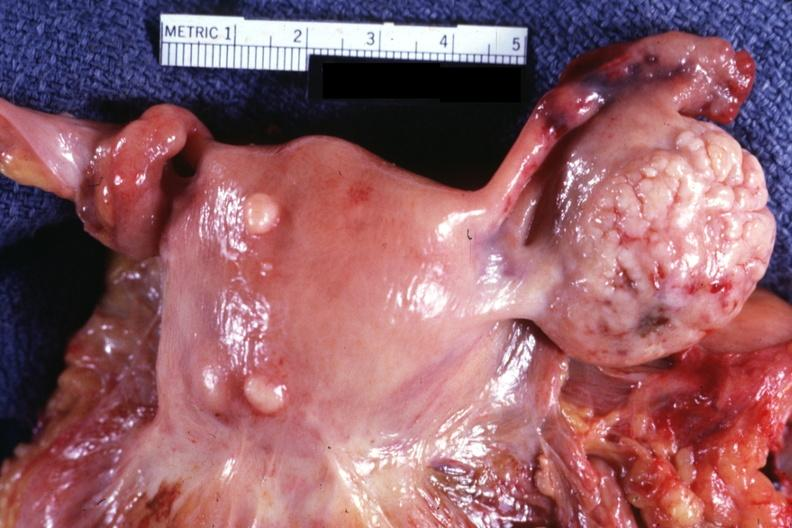where does this part belong to?
Answer the question using a single word or phrase. Female reproductive system 